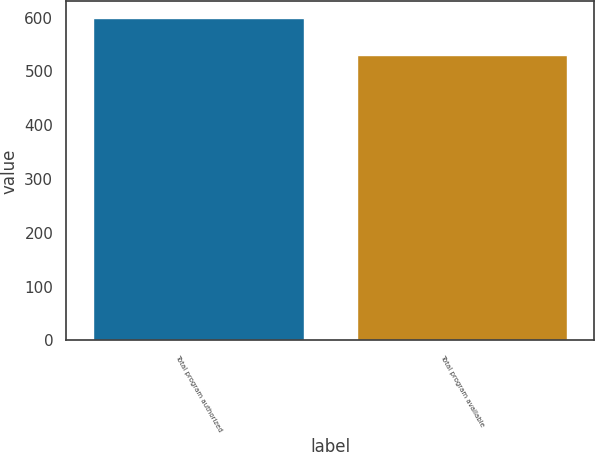Convert chart. <chart><loc_0><loc_0><loc_500><loc_500><bar_chart><fcel>Total program authorized<fcel>Total program available<nl><fcel>600<fcel>529.6<nl></chart> 